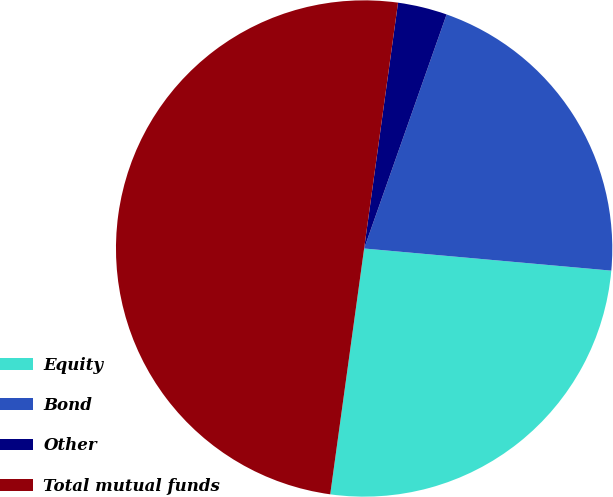Convert chart to OTSL. <chart><loc_0><loc_0><loc_500><loc_500><pie_chart><fcel>Equity<fcel>Bond<fcel>Other<fcel>Total mutual funds<nl><fcel>25.76%<fcel>21.03%<fcel>3.21%<fcel>50.0%<nl></chart> 